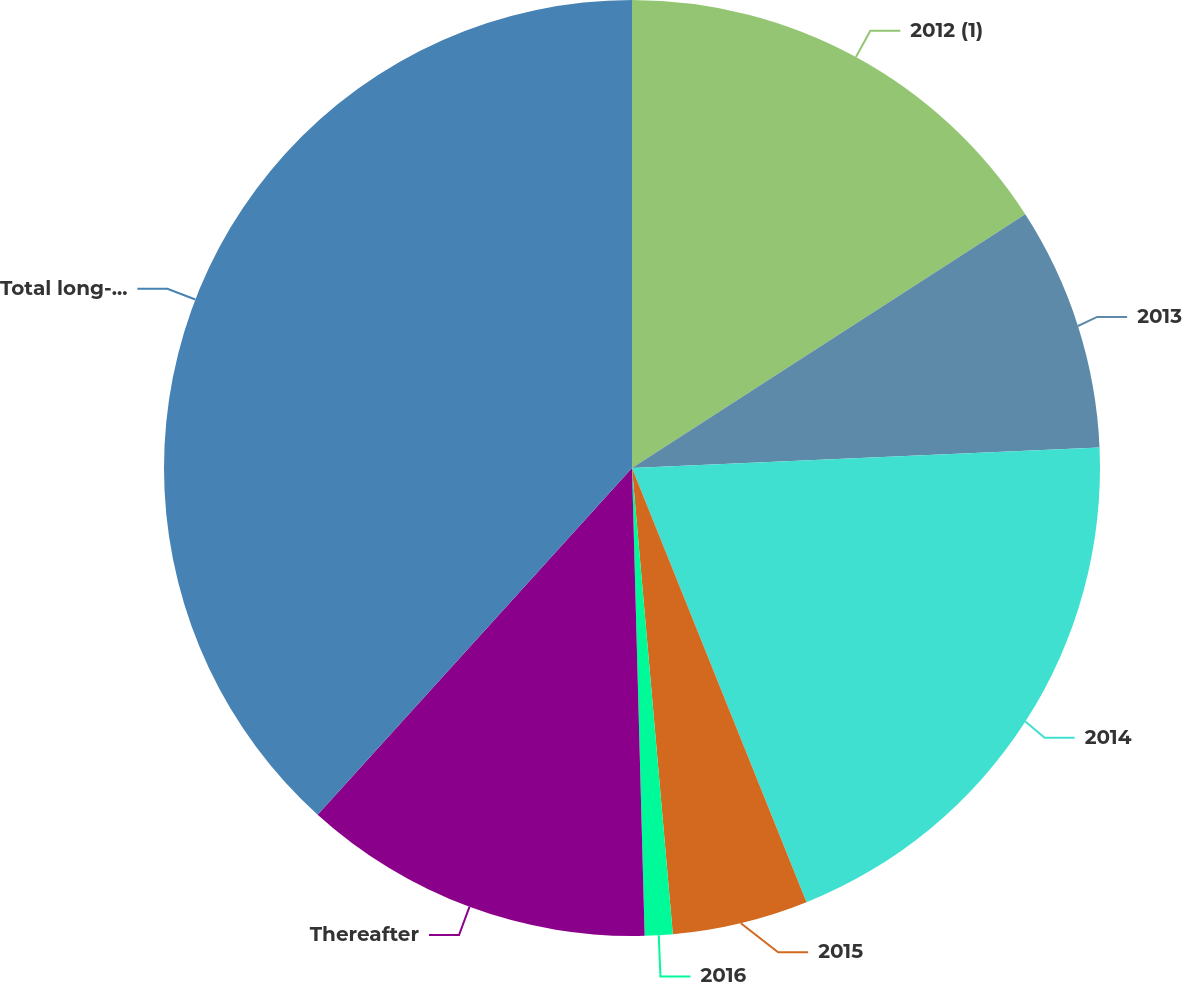<chart> <loc_0><loc_0><loc_500><loc_500><pie_chart><fcel>2012 (1)<fcel>2013<fcel>2014<fcel>2015<fcel>2016<fcel>Thereafter<fcel>Total long-term debt<nl><fcel>15.88%<fcel>8.42%<fcel>19.61%<fcel>4.69%<fcel>0.96%<fcel>12.15%<fcel>38.27%<nl></chart> 